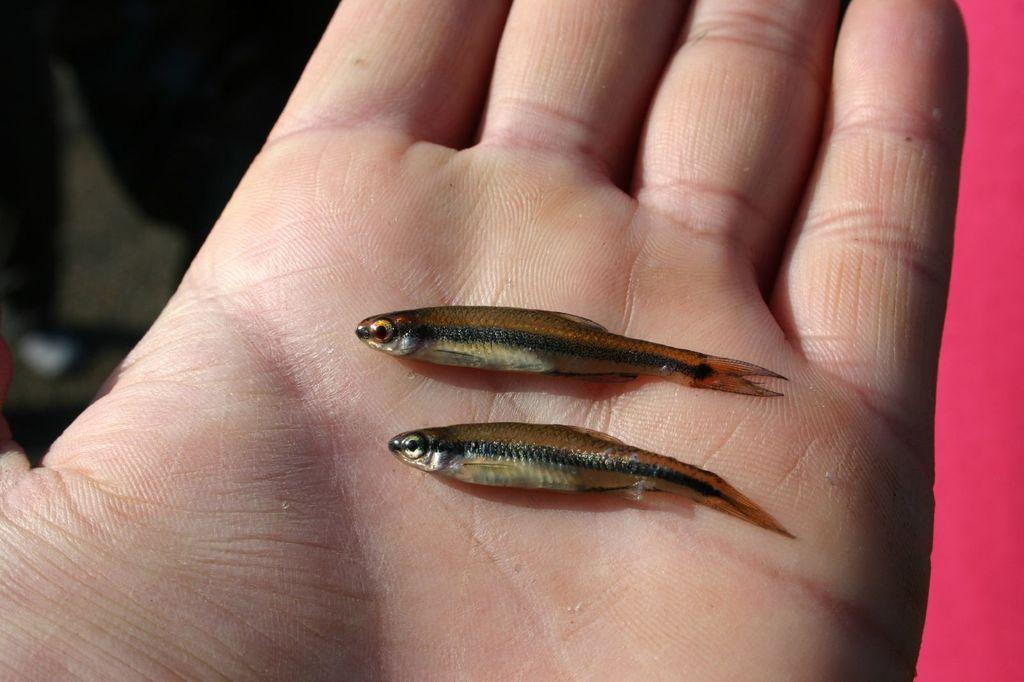Can you describe this image briefly? In the image there are two small fishes in a hand of a person. 